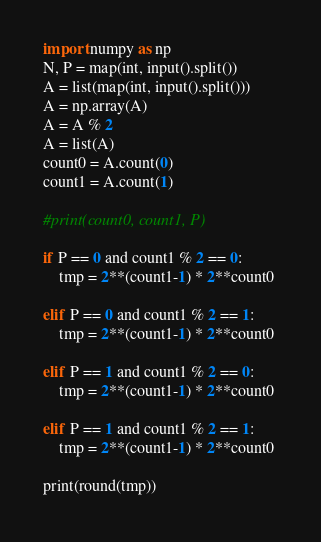Convert code to text. <code><loc_0><loc_0><loc_500><loc_500><_Python_>import numpy as np
N, P = map(int, input().split())
A = list(map(int, input().split()))
A = np.array(A)
A = A % 2
A = list(A)
count0 = A.count(0)
count1 = A.count(1)

#print(count0, count1, P)

if P == 0 and count1 % 2 == 0:
    tmp = 2**(count1-1) * 2**count0

elif P == 0 and count1 % 2 == 1:
    tmp = 2**(count1-1) * 2**count0

elif P == 1 and count1 % 2 == 0:
    tmp = 2**(count1-1) * 2**count0

elif P == 1 and count1 % 2 == 1:
    tmp = 2**(count1-1) * 2**count0 

print(round(tmp))</code> 